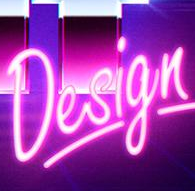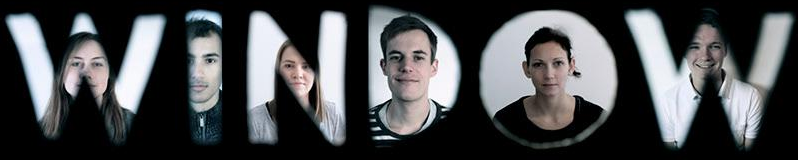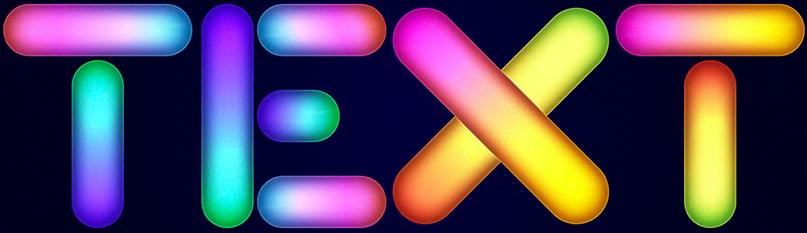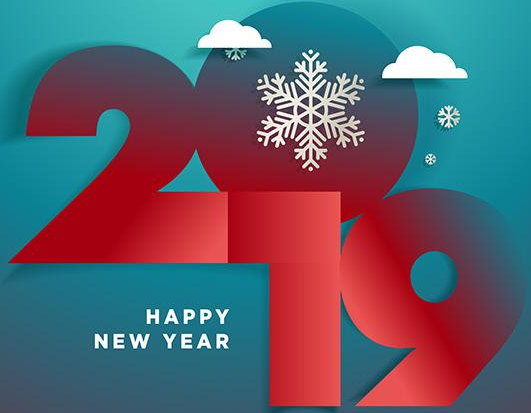What text is displayed in these images sequentially, separated by a semicolon? Design; WINDOW; TEXT; 2019 